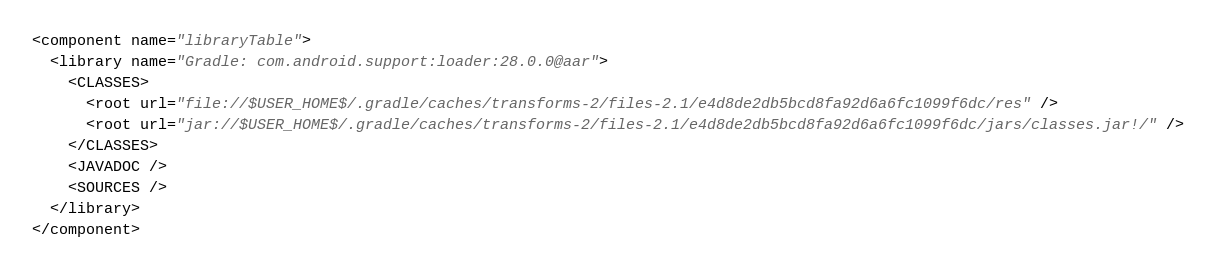<code> <loc_0><loc_0><loc_500><loc_500><_XML_><component name="libraryTable">
  <library name="Gradle: com.android.support:loader:28.0.0@aar">
    <CLASSES>
      <root url="file://$USER_HOME$/.gradle/caches/transforms-2/files-2.1/e4d8de2db5bcd8fa92d6a6fc1099f6dc/res" />
      <root url="jar://$USER_HOME$/.gradle/caches/transforms-2/files-2.1/e4d8de2db5bcd8fa92d6a6fc1099f6dc/jars/classes.jar!/" />
    </CLASSES>
    <JAVADOC />
    <SOURCES />
  </library>
</component></code> 